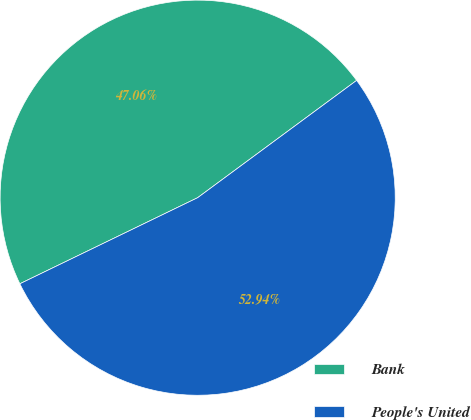Convert chart to OTSL. <chart><loc_0><loc_0><loc_500><loc_500><pie_chart><fcel>Bank<fcel>People's United<nl><fcel>47.06%<fcel>52.94%<nl></chart> 